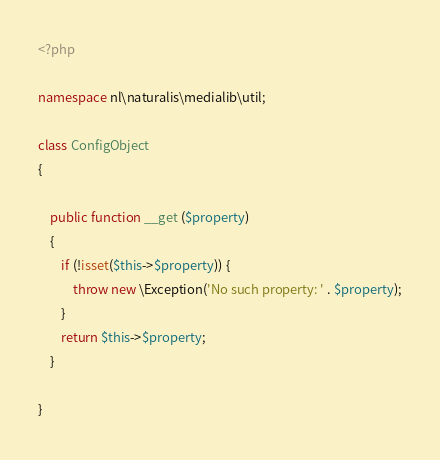<code> <loc_0><loc_0><loc_500><loc_500><_PHP_><?php

namespace nl\naturalis\medialib\util;

class ConfigObject
{

	public function __get ($property)
	{
		if (!isset($this->$property)) {
			throw new \Exception('No such property: ' . $property);
		}
		return $this->$property;
	}

}</code> 